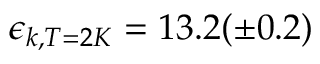Convert formula to latex. <formula><loc_0><loc_0><loc_500><loc_500>\epsilon _ { k , T = 2 K } = 1 3 . 2 ( \pm 0 . 2 )</formula> 